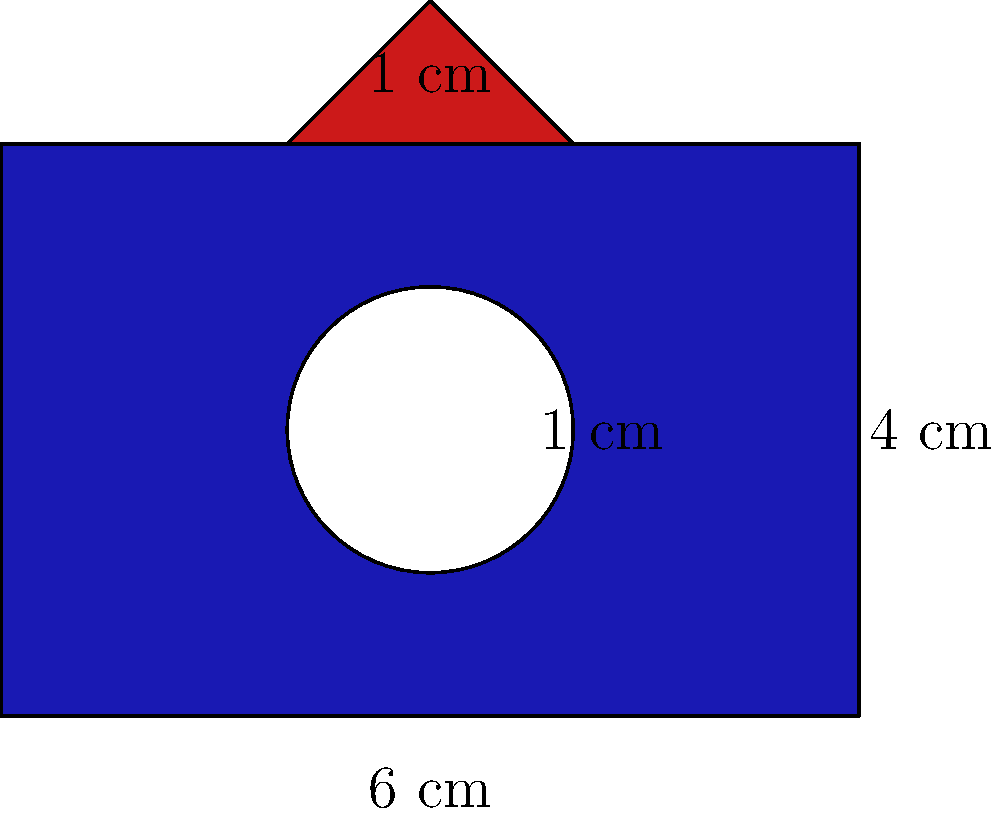The logo of Merlin United FC is composed of a blue rectangle with a white circle in the center and a red triangle on top. The rectangle measures 6 cm by 4 cm, the circle has a radius of 1 cm, and the triangle has a height of 1 cm and a base of 2 cm. What is the total area of the blue part of the logo in square centimeters? To find the area of the blue part, we need to:
1. Calculate the area of the rectangle
2. Subtract the area of the circle
3. Subtract the area of the triangle

Step 1: Area of the rectangle
$$ A_{rectangle} = l \times w = 6 \text{ cm} \times 4 \text{ cm} = 24 \text{ cm}^2 $$

Step 2: Area of the circle
$$ A_{circle} = \pi r^2 = \pi \times (1 \text{ cm})^2 = \pi \text{ cm}^2 $$

Step 3: Area of the triangle
$$ A_{triangle} = \frac{1}{2} \times b \times h = \frac{1}{2} \times 2 \text{ cm} \times 1 \text{ cm} = 1 \text{ cm}^2 $$

Step 4: Area of the blue part
$$ A_{blue} = A_{rectangle} - A_{circle} - A_{triangle} $$
$$ A_{blue} = 24 \text{ cm}^2 - \pi \text{ cm}^2 - 1 \text{ cm}^2 $$
$$ A_{blue} = 23 - \pi \text{ cm}^2 $$

Therefore, the area of the blue part is $23 - \pi$ square centimeters.
Answer: $23 - \pi \text{ cm}^2$ 